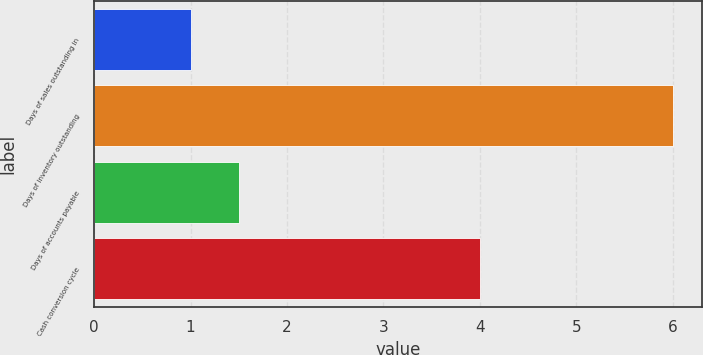Convert chart to OTSL. <chart><loc_0><loc_0><loc_500><loc_500><bar_chart><fcel>Days of sales outstanding in<fcel>Days of inventory outstanding<fcel>Days of accounts payable<fcel>Cash conversion cycle<nl><fcel>1<fcel>6<fcel>1.5<fcel>4<nl></chart> 